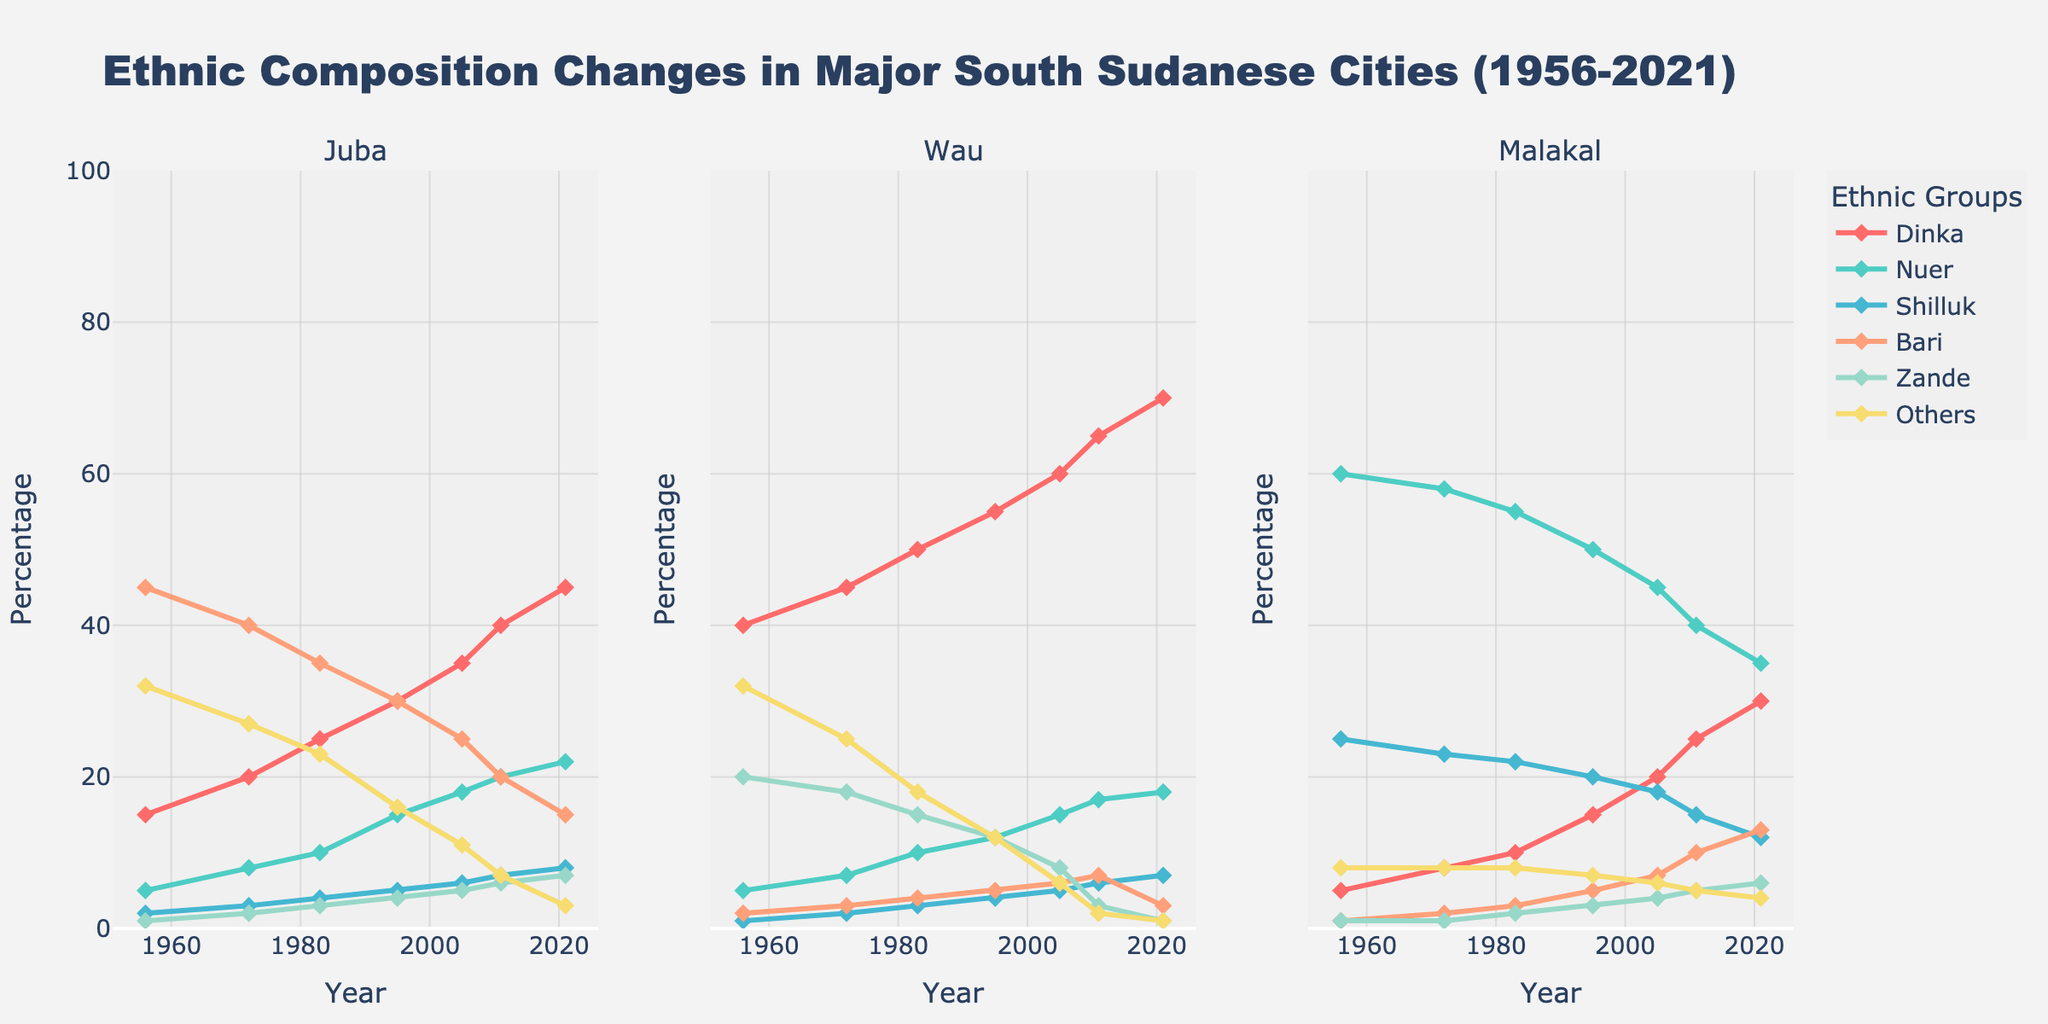What is the percentage increase in the Dinka population in Juba from 1956 to 2021? In 1956, the Dinka population in Juba was 15%. By 2021, it had increased to 45%. To find the percentage increase: (45 - 15) / 15 * 100 = 200%.
Answer: 200% Which ethnic group showed the greatest decrease in Juba between 1956 and 2021? The Bari population decreased from 45% in 1956 to 15% in 2021. This is a decrease of 30 percentage points, the largest decrease among the groups.
Answer: Bari By how many percentage points did the Shilluk population increase in Wau from 1956 to 2021? The Shilluk population in Wau went from 1% in 1956 to 7% in 2021. The increase is 7 - 1 = 6 percentage points.
Answer: 6 Compare the Nuer populations of Malakal and Wau in 2021; which city had a higher percentage, and by how much? In 2021, Malakal had 35% and Wau had 18% of the Nuer population. The difference is 35 - 18 = 17 percentage points, with Malakal having the higher percentage.
Answer: Malakal by 17 percentage points Which city had the smallest percentage of "Others" in 2021, and what was the percentage? In 2021, the "Others" population in Juba was 3%, in Wau it was 1%, and in Malakal it was 4%. Hence, Wau had the smallest percentage, which was 1%.
Answer: Wau, 1% How has the total composition of Bari and Zande populations changed in Wau from 1956 to 2021? In 1956, Bari had 2% and Zande had 20%, totaling 22%. In 2021, Bari had 3% and Zande had 1%, totaling 4%. The combined total decreased by 22 - 4 = 18 percentage points.
Answer: Decreased by 18 percentage points What is the average percentage of the Nuer population across the three cities in 2021? In 2021, the Nuer percentages were 22% (Juba), 18% (Wau), and 35% (Malakal). The average is (22 + 18 + 35) / 3 = 25%.
Answer: 25% Between which years did the Dinka population in Wau increase the most, and by how much? The Dinka population in Wau increased the most between 1956 and 1972, from 40% to 45%, an increase of 45-40 = 5 percentage points.
Answer: 1956-1972, by 5 percentage points What color represents the Shilluk ethnicity in the figure? The color representing the Shilluk ethnicity is blue, as indicated by the visual attributes in the figure.
Answer: Blue 